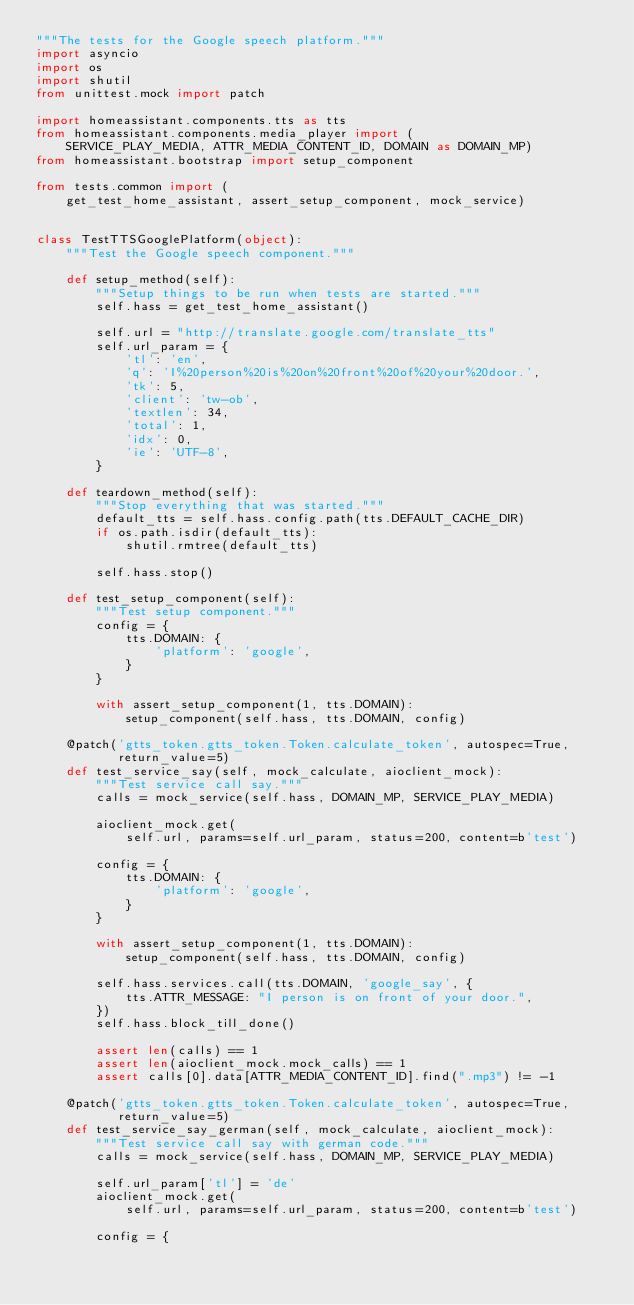<code> <loc_0><loc_0><loc_500><loc_500><_Python_>"""The tests for the Google speech platform."""
import asyncio
import os
import shutil
from unittest.mock import patch

import homeassistant.components.tts as tts
from homeassistant.components.media_player import (
    SERVICE_PLAY_MEDIA, ATTR_MEDIA_CONTENT_ID, DOMAIN as DOMAIN_MP)
from homeassistant.bootstrap import setup_component

from tests.common import (
    get_test_home_assistant, assert_setup_component, mock_service)


class TestTTSGooglePlatform(object):
    """Test the Google speech component."""

    def setup_method(self):
        """Setup things to be run when tests are started."""
        self.hass = get_test_home_assistant()

        self.url = "http://translate.google.com/translate_tts"
        self.url_param = {
            'tl': 'en',
            'q': 'I%20person%20is%20on%20front%20of%20your%20door.',
            'tk': 5,
            'client': 'tw-ob',
            'textlen': 34,
            'total': 1,
            'idx': 0,
            'ie': 'UTF-8',
        }

    def teardown_method(self):
        """Stop everything that was started."""
        default_tts = self.hass.config.path(tts.DEFAULT_CACHE_DIR)
        if os.path.isdir(default_tts):
            shutil.rmtree(default_tts)

        self.hass.stop()

    def test_setup_component(self):
        """Test setup component."""
        config = {
            tts.DOMAIN: {
                'platform': 'google',
            }
        }

        with assert_setup_component(1, tts.DOMAIN):
            setup_component(self.hass, tts.DOMAIN, config)

    @patch('gtts_token.gtts_token.Token.calculate_token', autospec=True,
           return_value=5)
    def test_service_say(self, mock_calculate, aioclient_mock):
        """Test service call say."""
        calls = mock_service(self.hass, DOMAIN_MP, SERVICE_PLAY_MEDIA)

        aioclient_mock.get(
            self.url, params=self.url_param, status=200, content=b'test')

        config = {
            tts.DOMAIN: {
                'platform': 'google',
            }
        }

        with assert_setup_component(1, tts.DOMAIN):
            setup_component(self.hass, tts.DOMAIN, config)

        self.hass.services.call(tts.DOMAIN, 'google_say', {
            tts.ATTR_MESSAGE: "I person is on front of your door.",
        })
        self.hass.block_till_done()

        assert len(calls) == 1
        assert len(aioclient_mock.mock_calls) == 1
        assert calls[0].data[ATTR_MEDIA_CONTENT_ID].find(".mp3") != -1

    @patch('gtts_token.gtts_token.Token.calculate_token', autospec=True,
           return_value=5)
    def test_service_say_german(self, mock_calculate, aioclient_mock):
        """Test service call say with german code."""
        calls = mock_service(self.hass, DOMAIN_MP, SERVICE_PLAY_MEDIA)

        self.url_param['tl'] = 'de'
        aioclient_mock.get(
            self.url, params=self.url_param, status=200, content=b'test')

        config = {</code> 